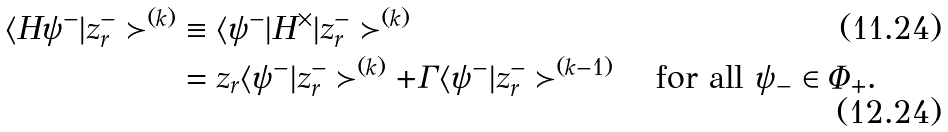<formula> <loc_0><loc_0><loc_500><loc_500>\langle H \psi ^ { - } | z _ { r } ^ { - } \succ ^ { ( k ) } & \equiv \langle \psi ^ { - } | H ^ { \times } | z _ { r } ^ { - } \succ ^ { ( k ) } \\ & = z _ { r } \langle \psi ^ { - } | z _ { r } ^ { - } \succ ^ { ( k ) } + \Gamma \langle \psi ^ { - } | z _ { r } ^ { - } \succ ^ { ( k - 1 ) } \quad \text {for all $\psi_{-} \in \Phi_{+}$.}</formula> 